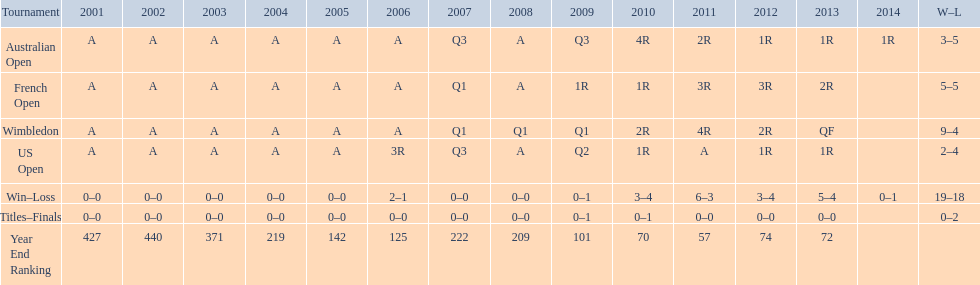Which annual ranking was superior, 2004 or 2011? 2011. 